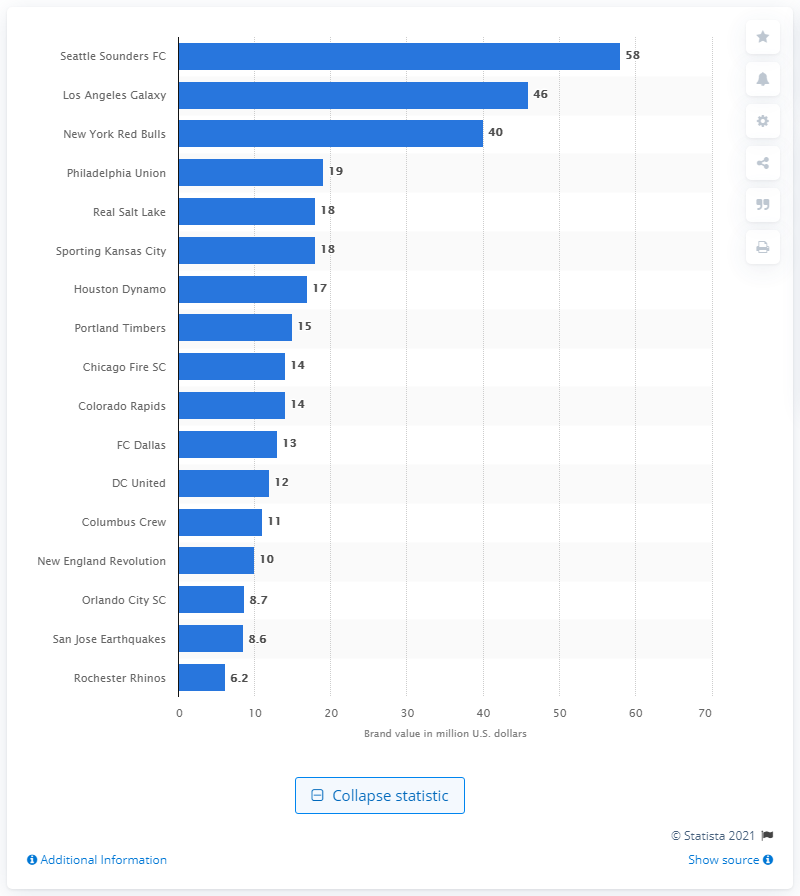Give some essential details in this illustration. The brand value of the Seattle Sounders FC in 2012 was estimated to be approximately $58 million. 